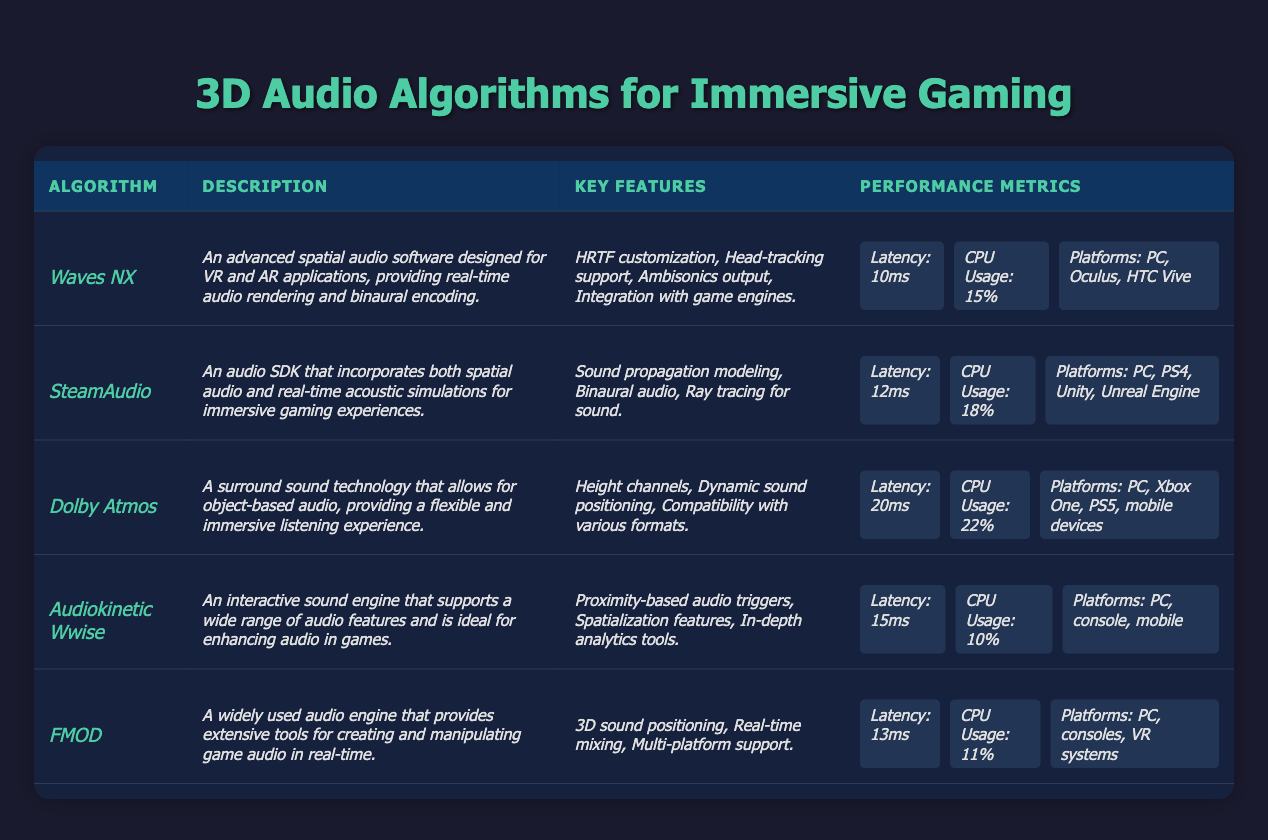What is the latency of the Waves NX algorithm? The table lists the latency for Waves NX under Performance Metrics, which is given as 10ms.
Answer: 10ms Which algorithm has the lowest CPU usage? By comparing the CPU Usage percentages in the Performance Metrics for all algorithms, Audiokinetic Wwise has the lowest at 10%.
Answer: Audiokinetic Wwise has the lowest CPU usage How many platforms does Dolby Atmos support? The Performance Metrics for Dolby Atmos lists the supported platforms as PC, Xbox One, PS5, and mobile devices, totaling four platforms.
Answer: 4 platforms What is the average latency of all algorithms? Add the latency values: 10 + 12 + 20 + 15 + 13 = 70. There are 5 algorithms, so the average latency is 70/5 = 14ms.
Answer: 14ms Does SteamAudio support real-time acoustic simulations? The description for SteamAudio states that it incorporates real-time acoustic simulations, confirming that it does.
Answer: Yes Which algorithm offers HRTF customization as a key feature? Looking in the Key Features section of the algorithms, HRTF customization is mentioned specifically for Waves NX.
Answer: Waves NX Which algorithms support mobile devices? The Performance Metrics section shows that only Dolby Atmos and Audiokinetic Wwise support mobile devices.
Answer: Dolby Atmos and Audiokinetic Wwise What is the combined CPU usage of Waves NX and FMOD? Adding the CPU Usage percentages for Waves NX (15%) and FMOD (11%) gives 15 + 11 = 26%.
Answer: 26% Is it true that all algorithms support PC? By examining the Supported Platforms under Performance Metrics, all algorithms list PC as a supported platform, confirming this fact.
Answer: Yes Which algorithm has the highest latency, and how much is it? From the latency values listed, Dolby Atmos has the highest latency at 20ms.
Answer: Dolby Atmos; 20ms 